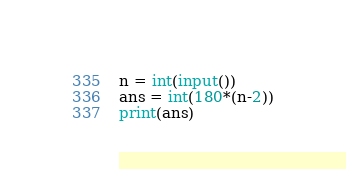Convert code to text. <code><loc_0><loc_0><loc_500><loc_500><_Python_>n = int(input())
ans = int(180*(n-2))
print(ans)
</code> 